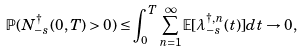Convert formula to latex. <formula><loc_0><loc_0><loc_500><loc_500>\mathbb { P } ( N _ { - s } ^ { \dagger } ( 0 , T ) > 0 ) \leq \int _ { 0 } ^ { T } \sum _ { n = 1 } ^ { \infty } \mathbb { E } [ \lambda _ { - s } ^ { \dagger , n } ( t ) ] d t \rightarrow 0 ,</formula> 